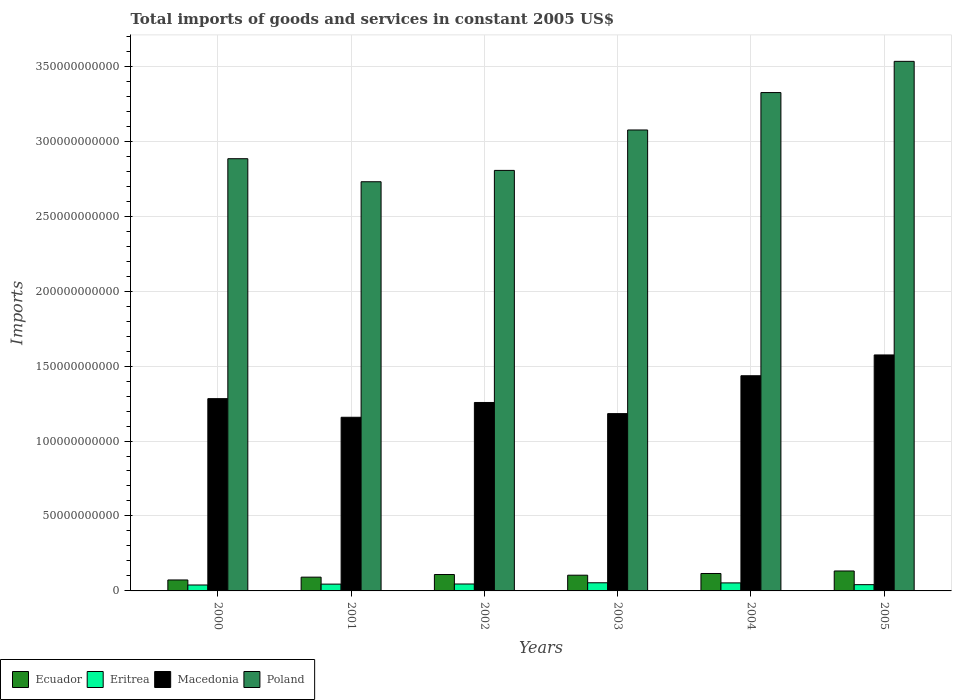How many different coloured bars are there?
Give a very brief answer. 4. Are the number of bars per tick equal to the number of legend labels?
Keep it short and to the point. Yes. Are the number of bars on each tick of the X-axis equal?
Give a very brief answer. Yes. How many bars are there on the 3rd tick from the left?
Give a very brief answer. 4. What is the label of the 1st group of bars from the left?
Ensure brevity in your answer.  2000. In how many cases, is the number of bars for a given year not equal to the number of legend labels?
Offer a terse response. 0. What is the total imports of goods and services in Ecuador in 2003?
Make the answer very short. 1.05e+1. Across all years, what is the maximum total imports of goods and services in Macedonia?
Your response must be concise. 1.57e+11. Across all years, what is the minimum total imports of goods and services in Eritrea?
Offer a very short reply. 3.96e+09. In which year was the total imports of goods and services in Ecuador minimum?
Your response must be concise. 2000. What is the total total imports of goods and services in Ecuador in the graph?
Your answer should be compact. 6.29e+1. What is the difference between the total imports of goods and services in Poland in 2002 and that in 2004?
Provide a succinct answer. -5.19e+1. What is the difference between the total imports of goods and services in Eritrea in 2005 and the total imports of goods and services in Ecuador in 2001?
Provide a short and direct response. -5.01e+09. What is the average total imports of goods and services in Macedonia per year?
Provide a succinct answer. 1.32e+11. In the year 2004, what is the difference between the total imports of goods and services in Macedonia and total imports of goods and services in Poland?
Your response must be concise. -1.89e+11. In how many years, is the total imports of goods and services in Eritrea greater than 230000000000 US$?
Provide a succinct answer. 0. What is the ratio of the total imports of goods and services in Ecuador in 2002 to that in 2003?
Give a very brief answer. 1.04. Is the total imports of goods and services in Poland in 2000 less than that in 2001?
Make the answer very short. No. Is the difference between the total imports of goods and services in Macedonia in 2004 and 2005 greater than the difference between the total imports of goods and services in Poland in 2004 and 2005?
Offer a very short reply. Yes. What is the difference between the highest and the second highest total imports of goods and services in Poland?
Ensure brevity in your answer.  2.08e+1. What is the difference between the highest and the lowest total imports of goods and services in Poland?
Keep it short and to the point. 8.03e+1. In how many years, is the total imports of goods and services in Poland greater than the average total imports of goods and services in Poland taken over all years?
Offer a terse response. 3. Is the sum of the total imports of goods and services in Eritrea in 2003 and 2004 greater than the maximum total imports of goods and services in Poland across all years?
Your answer should be very brief. No. What does the 3rd bar from the left in 2000 represents?
Provide a succinct answer. Macedonia. What does the 4th bar from the right in 2001 represents?
Provide a short and direct response. Ecuador. How many bars are there?
Your answer should be compact. 24. How many years are there in the graph?
Offer a very short reply. 6. Are the values on the major ticks of Y-axis written in scientific E-notation?
Provide a succinct answer. No. Does the graph contain any zero values?
Your response must be concise. No. Does the graph contain grids?
Offer a very short reply. Yes. How many legend labels are there?
Provide a short and direct response. 4. How are the legend labels stacked?
Your answer should be compact. Horizontal. What is the title of the graph?
Your response must be concise. Total imports of goods and services in constant 2005 US$. Does "Japan" appear as one of the legend labels in the graph?
Your answer should be compact. No. What is the label or title of the Y-axis?
Make the answer very short. Imports. What is the Imports in Ecuador in 2000?
Your answer should be very brief. 7.31e+09. What is the Imports of Eritrea in 2000?
Make the answer very short. 3.96e+09. What is the Imports of Macedonia in 2000?
Your answer should be compact. 1.28e+11. What is the Imports in Poland in 2000?
Ensure brevity in your answer.  2.88e+11. What is the Imports in Ecuador in 2001?
Your response must be concise. 9.19e+09. What is the Imports in Eritrea in 2001?
Provide a short and direct response. 4.54e+09. What is the Imports in Macedonia in 2001?
Offer a very short reply. 1.16e+11. What is the Imports in Poland in 2001?
Give a very brief answer. 2.73e+11. What is the Imports in Ecuador in 2002?
Ensure brevity in your answer.  1.09e+1. What is the Imports in Eritrea in 2002?
Your answer should be compact. 4.62e+09. What is the Imports of Macedonia in 2002?
Offer a terse response. 1.26e+11. What is the Imports in Poland in 2002?
Offer a terse response. 2.81e+11. What is the Imports of Ecuador in 2003?
Provide a short and direct response. 1.05e+1. What is the Imports in Eritrea in 2003?
Provide a succinct answer. 5.43e+09. What is the Imports in Macedonia in 2003?
Provide a succinct answer. 1.18e+11. What is the Imports of Poland in 2003?
Offer a terse response. 3.07e+11. What is the Imports in Ecuador in 2004?
Offer a very short reply. 1.16e+1. What is the Imports in Eritrea in 2004?
Your answer should be very brief. 5.35e+09. What is the Imports in Macedonia in 2004?
Ensure brevity in your answer.  1.44e+11. What is the Imports of Poland in 2004?
Offer a terse response. 3.32e+11. What is the Imports in Ecuador in 2005?
Offer a terse response. 1.33e+1. What is the Imports of Eritrea in 2005?
Your response must be concise. 4.18e+09. What is the Imports of Macedonia in 2005?
Keep it short and to the point. 1.57e+11. What is the Imports of Poland in 2005?
Provide a succinct answer. 3.53e+11. Across all years, what is the maximum Imports in Ecuador?
Ensure brevity in your answer.  1.33e+1. Across all years, what is the maximum Imports of Eritrea?
Give a very brief answer. 5.43e+09. Across all years, what is the maximum Imports of Macedonia?
Make the answer very short. 1.57e+11. Across all years, what is the maximum Imports in Poland?
Ensure brevity in your answer.  3.53e+11. Across all years, what is the minimum Imports of Ecuador?
Ensure brevity in your answer.  7.31e+09. Across all years, what is the minimum Imports in Eritrea?
Your response must be concise. 3.96e+09. Across all years, what is the minimum Imports of Macedonia?
Keep it short and to the point. 1.16e+11. Across all years, what is the minimum Imports in Poland?
Offer a terse response. 2.73e+11. What is the total Imports in Ecuador in the graph?
Offer a terse response. 6.29e+1. What is the total Imports in Eritrea in the graph?
Offer a very short reply. 2.81e+1. What is the total Imports in Macedonia in the graph?
Ensure brevity in your answer.  7.89e+11. What is the total Imports of Poland in the graph?
Provide a succinct answer. 1.83e+12. What is the difference between the Imports of Ecuador in 2000 and that in 2001?
Your answer should be compact. -1.88e+09. What is the difference between the Imports of Eritrea in 2000 and that in 2001?
Your answer should be compact. -5.78e+08. What is the difference between the Imports of Macedonia in 2000 and that in 2001?
Your response must be concise. 1.24e+1. What is the difference between the Imports in Poland in 2000 and that in 2001?
Keep it short and to the point. 1.54e+1. What is the difference between the Imports of Ecuador in 2000 and that in 2002?
Offer a terse response. -3.63e+09. What is the difference between the Imports in Eritrea in 2000 and that in 2002?
Keep it short and to the point. -6.64e+08. What is the difference between the Imports in Macedonia in 2000 and that in 2002?
Your answer should be very brief. 2.55e+09. What is the difference between the Imports of Poland in 2000 and that in 2002?
Keep it short and to the point. 7.79e+09. What is the difference between the Imports of Ecuador in 2000 and that in 2003?
Offer a very short reply. -3.18e+09. What is the difference between the Imports of Eritrea in 2000 and that in 2003?
Your answer should be very brief. -1.47e+09. What is the difference between the Imports in Macedonia in 2000 and that in 2003?
Give a very brief answer. 9.99e+09. What is the difference between the Imports of Poland in 2000 and that in 2003?
Your response must be concise. -1.92e+1. What is the difference between the Imports of Ecuador in 2000 and that in 2004?
Offer a terse response. -4.32e+09. What is the difference between the Imports of Eritrea in 2000 and that in 2004?
Provide a short and direct response. -1.40e+09. What is the difference between the Imports of Macedonia in 2000 and that in 2004?
Ensure brevity in your answer.  -1.53e+1. What is the difference between the Imports of Poland in 2000 and that in 2004?
Your response must be concise. -4.41e+1. What is the difference between the Imports in Ecuador in 2000 and that in 2005?
Provide a short and direct response. -6.00e+09. What is the difference between the Imports in Eritrea in 2000 and that in 2005?
Make the answer very short. -2.19e+08. What is the difference between the Imports of Macedonia in 2000 and that in 2005?
Offer a terse response. -2.92e+1. What is the difference between the Imports in Poland in 2000 and that in 2005?
Keep it short and to the point. -6.49e+1. What is the difference between the Imports of Ecuador in 2001 and that in 2002?
Provide a succinct answer. -1.75e+09. What is the difference between the Imports of Eritrea in 2001 and that in 2002?
Your answer should be very brief. -8.56e+07. What is the difference between the Imports of Macedonia in 2001 and that in 2002?
Your response must be concise. -9.87e+09. What is the difference between the Imports of Poland in 2001 and that in 2002?
Offer a very short reply. -7.57e+09. What is the difference between the Imports in Ecuador in 2001 and that in 2003?
Keep it short and to the point. -1.30e+09. What is the difference between the Imports in Eritrea in 2001 and that in 2003?
Provide a short and direct response. -8.95e+08. What is the difference between the Imports in Macedonia in 2001 and that in 2003?
Your response must be concise. -2.44e+09. What is the difference between the Imports of Poland in 2001 and that in 2003?
Offer a very short reply. -3.45e+1. What is the difference between the Imports of Ecuador in 2001 and that in 2004?
Offer a very short reply. -2.44e+09. What is the difference between the Imports in Eritrea in 2001 and that in 2004?
Give a very brief answer. -8.19e+08. What is the difference between the Imports of Macedonia in 2001 and that in 2004?
Your answer should be compact. -2.77e+1. What is the difference between the Imports in Poland in 2001 and that in 2004?
Keep it short and to the point. -5.95e+1. What is the difference between the Imports of Ecuador in 2001 and that in 2005?
Give a very brief answer. -4.12e+09. What is the difference between the Imports of Eritrea in 2001 and that in 2005?
Offer a terse response. 3.59e+08. What is the difference between the Imports of Macedonia in 2001 and that in 2005?
Give a very brief answer. -4.16e+1. What is the difference between the Imports in Poland in 2001 and that in 2005?
Make the answer very short. -8.03e+1. What is the difference between the Imports of Ecuador in 2002 and that in 2003?
Give a very brief answer. 4.44e+08. What is the difference between the Imports in Eritrea in 2002 and that in 2003?
Provide a short and direct response. -8.09e+08. What is the difference between the Imports in Macedonia in 2002 and that in 2003?
Ensure brevity in your answer.  7.44e+09. What is the difference between the Imports in Poland in 2002 and that in 2003?
Your answer should be compact. -2.70e+1. What is the difference between the Imports of Ecuador in 2002 and that in 2004?
Offer a terse response. -6.97e+08. What is the difference between the Imports of Eritrea in 2002 and that in 2004?
Ensure brevity in your answer.  -7.33e+08. What is the difference between the Imports of Macedonia in 2002 and that in 2004?
Offer a terse response. -1.78e+1. What is the difference between the Imports of Poland in 2002 and that in 2004?
Your answer should be very brief. -5.19e+1. What is the difference between the Imports in Ecuador in 2002 and that in 2005?
Make the answer very short. -2.37e+09. What is the difference between the Imports of Eritrea in 2002 and that in 2005?
Provide a short and direct response. 4.44e+08. What is the difference between the Imports of Macedonia in 2002 and that in 2005?
Give a very brief answer. -3.17e+1. What is the difference between the Imports of Poland in 2002 and that in 2005?
Make the answer very short. -7.27e+1. What is the difference between the Imports of Ecuador in 2003 and that in 2004?
Provide a succinct answer. -1.14e+09. What is the difference between the Imports of Eritrea in 2003 and that in 2004?
Provide a short and direct response. 7.59e+07. What is the difference between the Imports of Macedonia in 2003 and that in 2004?
Provide a succinct answer. -2.53e+1. What is the difference between the Imports of Poland in 2003 and that in 2004?
Offer a very short reply. -2.50e+1. What is the difference between the Imports of Ecuador in 2003 and that in 2005?
Keep it short and to the point. -2.82e+09. What is the difference between the Imports in Eritrea in 2003 and that in 2005?
Ensure brevity in your answer.  1.25e+09. What is the difference between the Imports of Macedonia in 2003 and that in 2005?
Provide a succinct answer. -3.91e+1. What is the difference between the Imports of Poland in 2003 and that in 2005?
Your answer should be compact. -4.58e+1. What is the difference between the Imports in Ecuador in 2004 and that in 2005?
Your response must be concise. -1.67e+09. What is the difference between the Imports of Eritrea in 2004 and that in 2005?
Your answer should be very brief. 1.18e+09. What is the difference between the Imports in Macedonia in 2004 and that in 2005?
Your answer should be compact. -1.39e+1. What is the difference between the Imports of Poland in 2004 and that in 2005?
Give a very brief answer. -2.08e+1. What is the difference between the Imports in Ecuador in 2000 and the Imports in Eritrea in 2001?
Provide a succinct answer. 2.77e+09. What is the difference between the Imports of Ecuador in 2000 and the Imports of Macedonia in 2001?
Make the answer very short. -1.09e+11. What is the difference between the Imports of Ecuador in 2000 and the Imports of Poland in 2001?
Provide a short and direct response. -2.66e+11. What is the difference between the Imports in Eritrea in 2000 and the Imports in Macedonia in 2001?
Make the answer very short. -1.12e+11. What is the difference between the Imports in Eritrea in 2000 and the Imports in Poland in 2001?
Provide a short and direct response. -2.69e+11. What is the difference between the Imports in Macedonia in 2000 and the Imports in Poland in 2001?
Offer a terse response. -1.45e+11. What is the difference between the Imports of Ecuador in 2000 and the Imports of Eritrea in 2002?
Provide a short and direct response. 2.69e+09. What is the difference between the Imports of Ecuador in 2000 and the Imports of Macedonia in 2002?
Provide a short and direct response. -1.18e+11. What is the difference between the Imports of Ecuador in 2000 and the Imports of Poland in 2002?
Keep it short and to the point. -2.73e+11. What is the difference between the Imports in Eritrea in 2000 and the Imports in Macedonia in 2002?
Your response must be concise. -1.22e+11. What is the difference between the Imports of Eritrea in 2000 and the Imports of Poland in 2002?
Provide a succinct answer. -2.77e+11. What is the difference between the Imports of Macedonia in 2000 and the Imports of Poland in 2002?
Give a very brief answer. -1.52e+11. What is the difference between the Imports of Ecuador in 2000 and the Imports of Eritrea in 2003?
Provide a short and direct response. 1.88e+09. What is the difference between the Imports in Ecuador in 2000 and the Imports in Macedonia in 2003?
Your response must be concise. -1.11e+11. What is the difference between the Imports of Ecuador in 2000 and the Imports of Poland in 2003?
Give a very brief answer. -3.00e+11. What is the difference between the Imports in Eritrea in 2000 and the Imports in Macedonia in 2003?
Offer a terse response. -1.14e+11. What is the difference between the Imports in Eritrea in 2000 and the Imports in Poland in 2003?
Your answer should be compact. -3.04e+11. What is the difference between the Imports in Macedonia in 2000 and the Imports in Poland in 2003?
Offer a very short reply. -1.79e+11. What is the difference between the Imports in Ecuador in 2000 and the Imports in Eritrea in 2004?
Ensure brevity in your answer.  1.95e+09. What is the difference between the Imports of Ecuador in 2000 and the Imports of Macedonia in 2004?
Make the answer very short. -1.36e+11. What is the difference between the Imports in Ecuador in 2000 and the Imports in Poland in 2004?
Ensure brevity in your answer.  -3.25e+11. What is the difference between the Imports of Eritrea in 2000 and the Imports of Macedonia in 2004?
Your response must be concise. -1.40e+11. What is the difference between the Imports in Eritrea in 2000 and the Imports in Poland in 2004?
Your response must be concise. -3.28e+11. What is the difference between the Imports in Macedonia in 2000 and the Imports in Poland in 2004?
Your response must be concise. -2.04e+11. What is the difference between the Imports in Ecuador in 2000 and the Imports in Eritrea in 2005?
Provide a short and direct response. 3.13e+09. What is the difference between the Imports of Ecuador in 2000 and the Imports of Macedonia in 2005?
Provide a succinct answer. -1.50e+11. What is the difference between the Imports in Ecuador in 2000 and the Imports in Poland in 2005?
Offer a terse response. -3.46e+11. What is the difference between the Imports in Eritrea in 2000 and the Imports in Macedonia in 2005?
Offer a very short reply. -1.53e+11. What is the difference between the Imports of Eritrea in 2000 and the Imports of Poland in 2005?
Your answer should be very brief. -3.49e+11. What is the difference between the Imports in Macedonia in 2000 and the Imports in Poland in 2005?
Your response must be concise. -2.25e+11. What is the difference between the Imports of Ecuador in 2001 and the Imports of Eritrea in 2002?
Make the answer very short. 4.57e+09. What is the difference between the Imports of Ecuador in 2001 and the Imports of Macedonia in 2002?
Make the answer very short. -1.17e+11. What is the difference between the Imports of Ecuador in 2001 and the Imports of Poland in 2002?
Provide a short and direct response. -2.71e+11. What is the difference between the Imports of Eritrea in 2001 and the Imports of Macedonia in 2002?
Your response must be concise. -1.21e+11. What is the difference between the Imports in Eritrea in 2001 and the Imports in Poland in 2002?
Keep it short and to the point. -2.76e+11. What is the difference between the Imports of Macedonia in 2001 and the Imports of Poland in 2002?
Keep it short and to the point. -1.65e+11. What is the difference between the Imports in Ecuador in 2001 and the Imports in Eritrea in 2003?
Provide a succinct answer. 3.76e+09. What is the difference between the Imports of Ecuador in 2001 and the Imports of Macedonia in 2003?
Offer a very short reply. -1.09e+11. What is the difference between the Imports of Ecuador in 2001 and the Imports of Poland in 2003?
Offer a very short reply. -2.98e+11. What is the difference between the Imports of Eritrea in 2001 and the Imports of Macedonia in 2003?
Offer a terse response. -1.14e+11. What is the difference between the Imports of Eritrea in 2001 and the Imports of Poland in 2003?
Provide a succinct answer. -3.03e+11. What is the difference between the Imports in Macedonia in 2001 and the Imports in Poland in 2003?
Your answer should be very brief. -1.92e+11. What is the difference between the Imports in Ecuador in 2001 and the Imports in Eritrea in 2004?
Keep it short and to the point. 3.83e+09. What is the difference between the Imports in Ecuador in 2001 and the Imports in Macedonia in 2004?
Provide a short and direct response. -1.34e+11. What is the difference between the Imports in Ecuador in 2001 and the Imports in Poland in 2004?
Give a very brief answer. -3.23e+11. What is the difference between the Imports in Eritrea in 2001 and the Imports in Macedonia in 2004?
Ensure brevity in your answer.  -1.39e+11. What is the difference between the Imports in Eritrea in 2001 and the Imports in Poland in 2004?
Provide a short and direct response. -3.28e+11. What is the difference between the Imports in Macedonia in 2001 and the Imports in Poland in 2004?
Your answer should be very brief. -2.17e+11. What is the difference between the Imports in Ecuador in 2001 and the Imports in Eritrea in 2005?
Offer a terse response. 5.01e+09. What is the difference between the Imports of Ecuador in 2001 and the Imports of Macedonia in 2005?
Your response must be concise. -1.48e+11. What is the difference between the Imports in Ecuador in 2001 and the Imports in Poland in 2005?
Your response must be concise. -3.44e+11. What is the difference between the Imports of Eritrea in 2001 and the Imports of Macedonia in 2005?
Keep it short and to the point. -1.53e+11. What is the difference between the Imports of Eritrea in 2001 and the Imports of Poland in 2005?
Provide a short and direct response. -3.49e+11. What is the difference between the Imports of Macedonia in 2001 and the Imports of Poland in 2005?
Offer a very short reply. -2.37e+11. What is the difference between the Imports in Ecuador in 2002 and the Imports in Eritrea in 2003?
Ensure brevity in your answer.  5.50e+09. What is the difference between the Imports in Ecuador in 2002 and the Imports in Macedonia in 2003?
Keep it short and to the point. -1.07e+11. What is the difference between the Imports of Ecuador in 2002 and the Imports of Poland in 2003?
Keep it short and to the point. -2.97e+11. What is the difference between the Imports of Eritrea in 2002 and the Imports of Macedonia in 2003?
Your answer should be compact. -1.14e+11. What is the difference between the Imports of Eritrea in 2002 and the Imports of Poland in 2003?
Give a very brief answer. -3.03e+11. What is the difference between the Imports of Macedonia in 2002 and the Imports of Poland in 2003?
Your answer should be compact. -1.82e+11. What is the difference between the Imports of Ecuador in 2002 and the Imports of Eritrea in 2004?
Offer a terse response. 5.58e+09. What is the difference between the Imports in Ecuador in 2002 and the Imports in Macedonia in 2004?
Provide a succinct answer. -1.33e+11. What is the difference between the Imports of Ecuador in 2002 and the Imports of Poland in 2004?
Ensure brevity in your answer.  -3.21e+11. What is the difference between the Imports of Eritrea in 2002 and the Imports of Macedonia in 2004?
Offer a very short reply. -1.39e+11. What is the difference between the Imports of Eritrea in 2002 and the Imports of Poland in 2004?
Make the answer very short. -3.28e+11. What is the difference between the Imports of Macedonia in 2002 and the Imports of Poland in 2004?
Provide a short and direct response. -2.07e+11. What is the difference between the Imports of Ecuador in 2002 and the Imports of Eritrea in 2005?
Your response must be concise. 6.76e+09. What is the difference between the Imports of Ecuador in 2002 and the Imports of Macedonia in 2005?
Your answer should be very brief. -1.46e+11. What is the difference between the Imports of Ecuador in 2002 and the Imports of Poland in 2005?
Make the answer very short. -3.42e+11. What is the difference between the Imports of Eritrea in 2002 and the Imports of Macedonia in 2005?
Your answer should be compact. -1.53e+11. What is the difference between the Imports in Eritrea in 2002 and the Imports in Poland in 2005?
Provide a short and direct response. -3.49e+11. What is the difference between the Imports of Macedonia in 2002 and the Imports of Poland in 2005?
Give a very brief answer. -2.28e+11. What is the difference between the Imports in Ecuador in 2003 and the Imports in Eritrea in 2004?
Give a very brief answer. 5.14e+09. What is the difference between the Imports in Ecuador in 2003 and the Imports in Macedonia in 2004?
Make the answer very short. -1.33e+11. What is the difference between the Imports of Ecuador in 2003 and the Imports of Poland in 2004?
Make the answer very short. -3.22e+11. What is the difference between the Imports in Eritrea in 2003 and the Imports in Macedonia in 2004?
Your answer should be very brief. -1.38e+11. What is the difference between the Imports in Eritrea in 2003 and the Imports in Poland in 2004?
Offer a very short reply. -3.27e+11. What is the difference between the Imports of Macedonia in 2003 and the Imports of Poland in 2004?
Provide a short and direct response. -2.14e+11. What is the difference between the Imports of Ecuador in 2003 and the Imports of Eritrea in 2005?
Give a very brief answer. 6.31e+09. What is the difference between the Imports in Ecuador in 2003 and the Imports in Macedonia in 2005?
Offer a terse response. -1.47e+11. What is the difference between the Imports in Ecuador in 2003 and the Imports in Poland in 2005?
Provide a succinct answer. -3.43e+11. What is the difference between the Imports of Eritrea in 2003 and the Imports of Macedonia in 2005?
Make the answer very short. -1.52e+11. What is the difference between the Imports in Eritrea in 2003 and the Imports in Poland in 2005?
Provide a succinct answer. -3.48e+11. What is the difference between the Imports of Macedonia in 2003 and the Imports of Poland in 2005?
Offer a terse response. -2.35e+11. What is the difference between the Imports in Ecuador in 2004 and the Imports in Eritrea in 2005?
Give a very brief answer. 7.45e+09. What is the difference between the Imports of Ecuador in 2004 and the Imports of Macedonia in 2005?
Provide a short and direct response. -1.46e+11. What is the difference between the Imports of Ecuador in 2004 and the Imports of Poland in 2005?
Your response must be concise. -3.42e+11. What is the difference between the Imports of Eritrea in 2004 and the Imports of Macedonia in 2005?
Your response must be concise. -1.52e+11. What is the difference between the Imports in Eritrea in 2004 and the Imports in Poland in 2005?
Make the answer very short. -3.48e+11. What is the difference between the Imports of Macedonia in 2004 and the Imports of Poland in 2005?
Ensure brevity in your answer.  -2.10e+11. What is the average Imports in Ecuador per year?
Provide a short and direct response. 1.05e+1. What is the average Imports in Eritrea per year?
Keep it short and to the point. 4.68e+09. What is the average Imports in Macedonia per year?
Your response must be concise. 1.32e+11. What is the average Imports in Poland per year?
Your answer should be compact. 3.06e+11. In the year 2000, what is the difference between the Imports of Ecuador and Imports of Eritrea?
Keep it short and to the point. 3.35e+09. In the year 2000, what is the difference between the Imports in Ecuador and Imports in Macedonia?
Keep it short and to the point. -1.21e+11. In the year 2000, what is the difference between the Imports of Ecuador and Imports of Poland?
Your answer should be very brief. -2.81e+11. In the year 2000, what is the difference between the Imports of Eritrea and Imports of Macedonia?
Offer a terse response. -1.24e+11. In the year 2000, what is the difference between the Imports of Eritrea and Imports of Poland?
Your response must be concise. -2.84e+11. In the year 2000, what is the difference between the Imports of Macedonia and Imports of Poland?
Your answer should be very brief. -1.60e+11. In the year 2001, what is the difference between the Imports in Ecuador and Imports in Eritrea?
Keep it short and to the point. 4.65e+09. In the year 2001, what is the difference between the Imports of Ecuador and Imports of Macedonia?
Ensure brevity in your answer.  -1.07e+11. In the year 2001, what is the difference between the Imports in Ecuador and Imports in Poland?
Your answer should be compact. -2.64e+11. In the year 2001, what is the difference between the Imports of Eritrea and Imports of Macedonia?
Provide a succinct answer. -1.11e+11. In the year 2001, what is the difference between the Imports in Eritrea and Imports in Poland?
Your response must be concise. -2.68e+11. In the year 2001, what is the difference between the Imports of Macedonia and Imports of Poland?
Give a very brief answer. -1.57e+11. In the year 2002, what is the difference between the Imports of Ecuador and Imports of Eritrea?
Your response must be concise. 6.31e+09. In the year 2002, what is the difference between the Imports in Ecuador and Imports in Macedonia?
Ensure brevity in your answer.  -1.15e+11. In the year 2002, what is the difference between the Imports in Ecuador and Imports in Poland?
Your answer should be very brief. -2.70e+11. In the year 2002, what is the difference between the Imports in Eritrea and Imports in Macedonia?
Offer a very short reply. -1.21e+11. In the year 2002, what is the difference between the Imports in Eritrea and Imports in Poland?
Your answer should be very brief. -2.76e+11. In the year 2002, what is the difference between the Imports in Macedonia and Imports in Poland?
Your answer should be very brief. -1.55e+11. In the year 2003, what is the difference between the Imports of Ecuador and Imports of Eritrea?
Ensure brevity in your answer.  5.06e+09. In the year 2003, what is the difference between the Imports in Ecuador and Imports in Macedonia?
Offer a very short reply. -1.08e+11. In the year 2003, what is the difference between the Imports of Ecuador and Imports of Poland?
Your answer should be very brief. -2.97e+11. In the year 2003, what is the difference between the Imports of Eritrea and Imports of Macedonia?
Provide a short and direct response. -1.13e+11. In the year 2003, what is the difference between the Imports of Eritrea and Imports of Poland?
Offer a very short reply. -3.02e+11. In the year 2003, what is the difference between the Imports of Macedonia and Imports of Poland?
Your response must be concise. -1.89e+11. In the year 2004, what is the difference between the Imports in Ecuador and Imports in Eritrea?
Provide a short and direct response. 6.28e+09. In the year 2004, what is the difference between the Imports of Ecuador and Imports of Macedonia?
Provide a succinct answer. -1.32e+11. In the year 2004, what is the difference between the Imports in Ecuador and Imports in Poland?
Ensure brevity in your answer.  -3.21e+11. In the year 2004, what is the difference between the Imports in Eritrea and Imports in Macedonia?
Offer a very short reply. -1.38e+11. In the year 2004, what is the difference between the Imports in Eritrea and Imports in Poland?
Your answer should be very brief. -3.27e+11. In the year 2004, what is the difference between the Imports in Macedonia and Imports in Poland?
Keep it short and to the point. -1.89e+11. In the year 2005, what is the difference between the Imports of Ecuador and Imports of Eritrea?
Give a very brief answer. 9.13e+09. In the year 2005, what is the difference between the Imports in Ecuador and Imports in Macedonia?
Ensure brevity in your answer.  -1.44e+11. In the year 2005, what is the difference between the Imports in Ecuador and Imports in Poland?
Your response must be concise. -3.40e+11. In the year 2005, what is the difference between the Imports in Eritrea and Imports in Macedonia?
Your answer should be very brief. -1.53e+11. In the year 2005, what is the difference between the Imports of Eritrea and Imports of Poland?
Make the answer very short. -3.49e+11. In the year 2005, what is the difference between the Imports in Macedonia and Imports in Poland?
Offer a very short reply. -1.96e+11. What is the ratio of the Imports in Ecuador in 2000 to that in 2001?
Keep it short and to the point. 0.8. What is the ratio of the Imports of Eritrea in 2000 to that in 2001?
Make the answer very short. 0.87. What is the ratio of the Imports in Macedonia in 2000 to that in 2001?
Offer a terse response. 1.11. What is the ratio of the Imports in Poland in 2000 to that in 2001?
Your answer should be very brief. 1.06. What is the ratio of the Imports of Ecuador in 2000 to that in 2002?
Your answer should be compact. 0.67. What is the ratio of the Imports in Eritrea in 2000 to that in 2002?
Provide a succinct answer. 0.86. What is the ratio of the Imports of Macedonia in 2000 to that in 2002?
Offer a terse response. 1.02. What is the ratio of the Imports of Poland in 2000 to that in 2002?
Give a very brief answer. 1.03. What is the ratio of the Imports of Ecuador in 2000 to that in 2003?
Make the answer very short. 0.7. What is the ratio of the Imports in Eritrea in 2000 to that in 2003?
Give a very brief answer. 0.73. What is the ratio of the Imports in Macedonia in 2000 to that in 2003?
Ensure brevity in your answer.  1.08. What is the ratio of the Imports of Poland in 2000 to that in 2003?
Your answer should be compact. 0.94. What is the ratio of the Imports in Ecuador in 2000 to that in 2004?
Your answer should be compact. 0.63. What is the ratio of the Imports in Eritrea in 2000 to that in 2004?
Make the answer very short. 0.74. What is the ratio of the Imports in Macedonia in 2000 to that in 2004?
Your answer should be compact. 0.89. What is the ratio of the Imports in Poland in 2000 to that in 2004?
Provide a short and direct response. 0.87. What is the ratio of the Imports in Ecuador in 2000 to that in 2005?
Ensure brevity in your answer.  0.55. What is the ratio of the Imports in Eritrea in 2000 to that in 2005?
Ensure brevity in your answer.  0.95. What is the ratio of the Imports in Macedonia in 2000 to that in 2005?
Keep it short and to the point. 0.81. What is the ratio of the Imports of Poland in 2000 to that in 2005?
Make the answer very short. 0.82. What is the ratio of the Imports of Ecuador in 2001 to that in 2002?
Provide a short and direct response. 0.84. What is the ratio of the Imports in Eritrea in 2001 to that in 2002?
Offer a terse response. 0.98. What is the ratio of the Imports in Macedonia in 2001 to that in 2002?
Provide a succinct answer. 0.92. What is the ratio of the Imports in Ecuador in 2001 to that in 2003?
Make the answer very short. 0.88. What is the ratio of the Imports in Eritrea in 2001 to that in 2003?
Offer a very short reply. 0.84. What is the ratio of the Imports of Macedonia in 2001 to that in 2003?
Offer a very short reply. 0.98. What is the ratio of the Imports of Poland in 2001 to that in 2003?
Ensure brevity in your answer.  0.89. What is the ratio of the Imports of Ecuador in 2001 to that in 2004?
Offer a terse response. 0.79. What is the ratio of the Imports in Eritrea in 2001 to that in 2004?
Provide a succinct answer. 0.85. What is the ratio of the Imports in Macedonia in 2001 to that in 2004?
Your response must be concise. 0.81. What is the ratio of the Imports of Poland in 2001 to that in 2004?
Make the answer very short. 0.82. What is the ratio of the Imports of Ecuador in 2001 to that in 2005?
Offer a very short reply. 0.69. What is the ratio of the Imports in Eritrea in 2001 to that in 2005?
Offer a terse response. 1.09. What is the ratio of the Imports in Macedonia in 2001 to that in 2005?
Your answer should be very brief. 0.74. What is the ratio of the Imports of Poland in 2001 to that in 2005?
Your answer should be compact. 0.77. What is the ratio of the Imports of Ecuador in 2002 to that in 2003?
Make the answer very short. 1.04. What is the ratio of the Imports in Eritrea in 2002 to that in 2003?
Offer a very short reply. 0.85. What is the ratio of the Imports in Macedonia in 2002 to that in 2003?
Offer a terse response. 1.06. What is the ratio of the Imports in Poland in 2002 to that in 2003?
Make the answer very short. 0.91. What is the ratio of the Imports in Ecuador in 2002 to that in 2004?
Your response must be concise. 0.94. What is the ratio of the Imports of Eritrea in 2002 to that in 2004?
Offer a very short reply. 0.86. What is the ratio of the Imports in Macedonia in 2002 to that in 2004?
Offer a terse response. 0.88. What is the ratio of the Imports of Poland in 2002 to that in 2004?
Ensure brevity in your answer.  0.84. What is the ratio of the Imports in Ecuador in 2002 to that in 2005?
Provide a succinct answer. 0.82. What is the ratio of the Imports of Eritrea in 2002 to that in 2005?
Your answer should be very brief. 1.11. What is the ratio of the Imports in Macedonia in 2002 to that in 2005?
Provide a short and direct response. 0.8. What is the ratio of the Imports in Poland in 2002 to that in 2005?
Offer a very short reply. 0.79. What is the ratio of the Imports in Ecuador in 2003 to that in 2004?
Offer a terse response. 0.9. What is the ratio of the Imports in Eritrea in 2003 to that in 2004?
Ensure brevity in your answer.  1.01. What is the ratio of the Imports of Macedonia in 2003 to that in 2004?
Your answer should be compact. 0.82. What is the ratio of the Imports of Poland in 2003 to that in 2004?
Give a very brief answer. 0.92. What is the ratio of the Imports in Ecuador in 2003 to that in 2005?
Provide a short and direct response. 0.79. What is the ratio of the Imports of Eritrea in 2003 to that in 2005?
Ensure brevity in your answer.  1.3. What is the ratio of the Imports in Macedonia in 2003 to that in 2005?
Offer a terse response. 0.75. What is the ratio of the Imports of Poland in 2003 to that in 2005?
Your answer should be compact. 0.87. What is the ratio of the Imports of Ecuador in 2004 to that in 2005?
Provide a short and direct response. 0.87. What is the ratio of the Imports in Eritrea in 2004 to that in 2005?
Give a very brief answer. 1.28. What is the ratio of the Imports of Macedonia in 2004 to that in 2005?
Give a very brief answer. 0.91. What is the ratio of the Imports of Poland in 2004 to that in 2005?
Give a very brief answer. 0.94. What is the difference between the highest and the second highest Imports of Ecuador?
Provide a short and direct response. 1.67e+09. What is the difference between the highest and the second highest Imports in Eritrea?
Ensure brevity in your answer.  7.59e+07. What is the difference between the highest and the second highest Imports in Macedonia?
Provide a short and direct response. 1.39e+1. What is the difference between the highest and the second highest Imports of Poland?
Make the answer very short. 2.08e+1. What is the difference between the highest and the lowest Imports in Ecuador?
Offer a very short reply. 6.00e+09. What is the difference between the highest and the lowest Imports of Eritrea?
Offer a terse response. 1.47e+09. What is the difference between the highest and the lowest Imports in Macedonia?
Provide a short and direct response. 4.16e+1. What is the difference between the highest and the lowest Imports of Poland?
Your answer should be compact. 8.03e+1. 